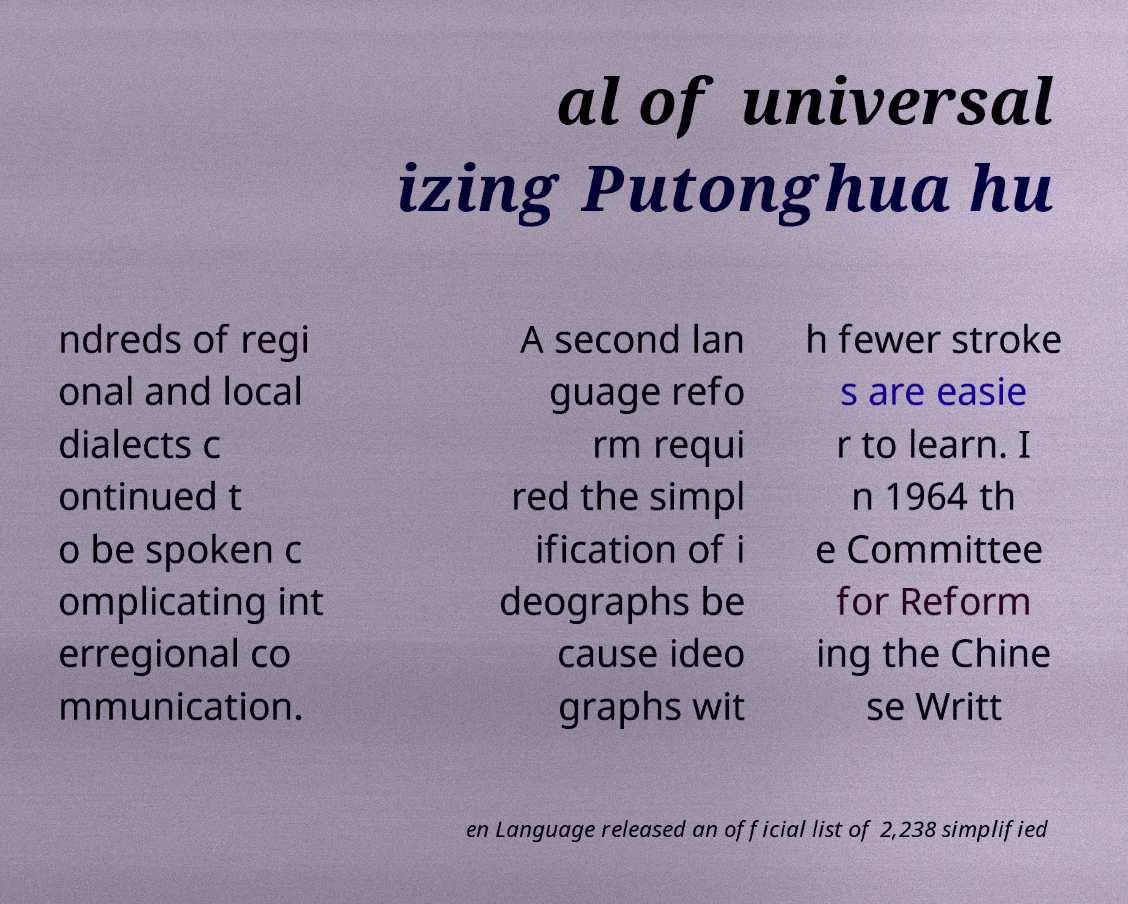Could you extract and type out the text from this image? al of universal izing Putonghua hu ndreds of regi onal and local dialects c ontinued t o be spoken c omplicating int erregional co mmunication. A second lan guage refo rm requi red the simpl ification of i deographs be cause ideo graphs wit h fewer stroke s are easie r to learn. I n 1964 th e Committee for Reform ing the Chine se Writt en Language released an official list of 2,238 simplified 